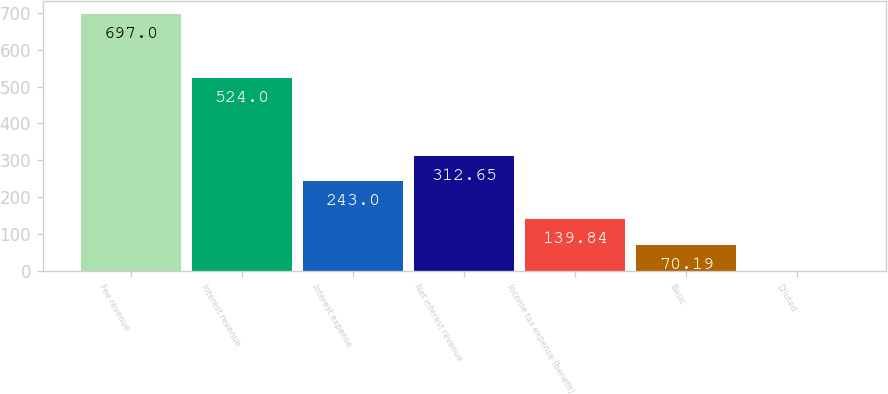Convert chart. <chart><loc_0><loc_0><loc_500><loc_500><bar_chart><fcel>Fee revenue<fcel>Interest revenue<fcel>Interest expense<fcel>Net interest revenue<fcel>Income tax expense (benefit)<fcel>Basic<fcel>Diluted<nl><fcel>697<fcel>524<fcel>243<fcel>312.65<fcel>139.84<fcel>70.19<fcel>0.54<nl></chart> 